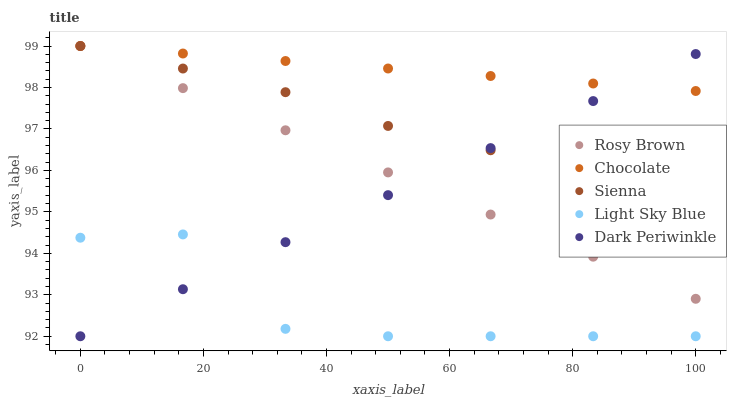Does Light Sky Blue have the minimum area under the curve?
Answer yes or no. Yes. Does Chocolate have the maximum area under the curve?
Answer yes or no. Yes. Does Rosy Brown have the minimum area under the curve?
Answer yes or no. No. Does Rosy Brown have the maximum area under the curve?
Answer yes or no. No. Is Rosy Brown the smoothest?
Answer yes or no. Yes. Is Light Sky Blue the roughest?
Answer yes or no. Yes. Is Dark Periwinkle the smoothest?
Answer yes or no. No. Is Dark Periwinkle the roughest?
Answer yes or no. No. Does Dark Periwinkle have the lowest value?
Answer yes or no. Yes. Does Rosy Brown have the lowest value?
Answer yes or no. No. Does Chocolate have the highest value?
Answer yes or no. Yes. Does Dark Periwinkle have the highest value?
Answer yes or no. No. Is Light Sky Blue less than Rosy Brown?
Answer yes or no. Yes. Is Sienna greater than Light Sky Blue?
Answer yes or no. Yes. Does Dark Periwinkle intersect Rosy Brown?
Answer yes or no. Yes. Is Dark Periwinkle less than Rosy Brown?
Answer yes or no. No. Is Dark Periwinkle greater than Rosy Brown?
Answer yes or no. No. Does Light Sky Blue intersect Rosy Brown?
Answer yes or no. No. 